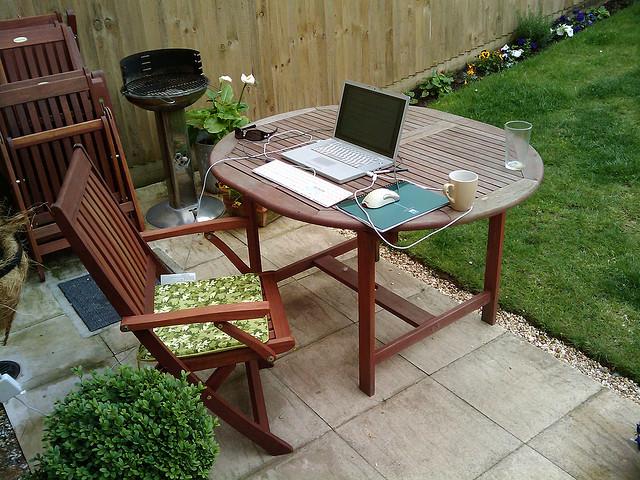Does this chair look new?
Answer briefly. Yes. What is all over the pavers under the table?
Keep it brief. Stones. Is this table and chair outside?
Quick response, please. Yes. What is in front of the chair?
Quick response, please. Table. Is there a lunch box on the table?
Concise answer only. No. What color is the mat on top of the chair?
Be succinct. Green. How many people can sit at the table?
Answer briefly. 1. 